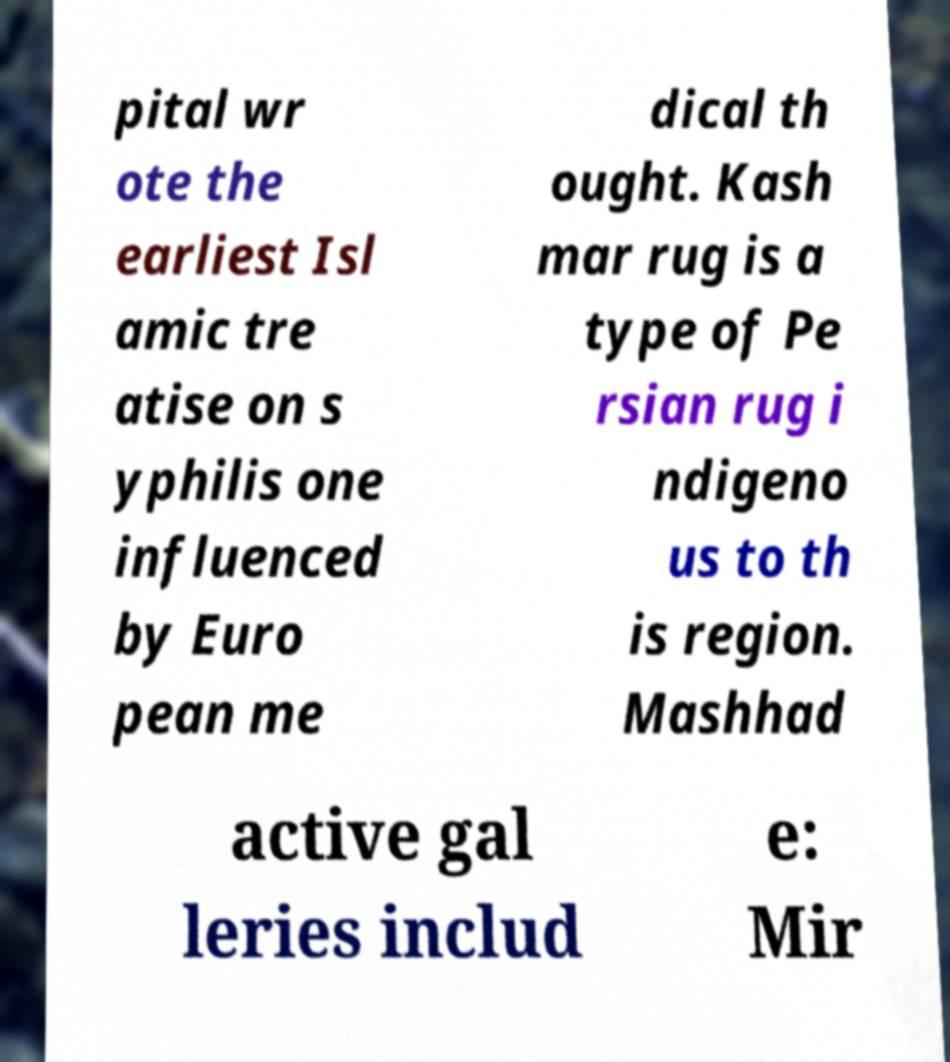Could you extract and type out the text from this image? pital wr ote the earliest Isl amic tre atise on s yphilis one influenced by Euro pean me dical th ought. Kash mar rug is a type of Pe rsian rug i ndigeno us to th is region. Mashhad active gal leries includ e: Mir 